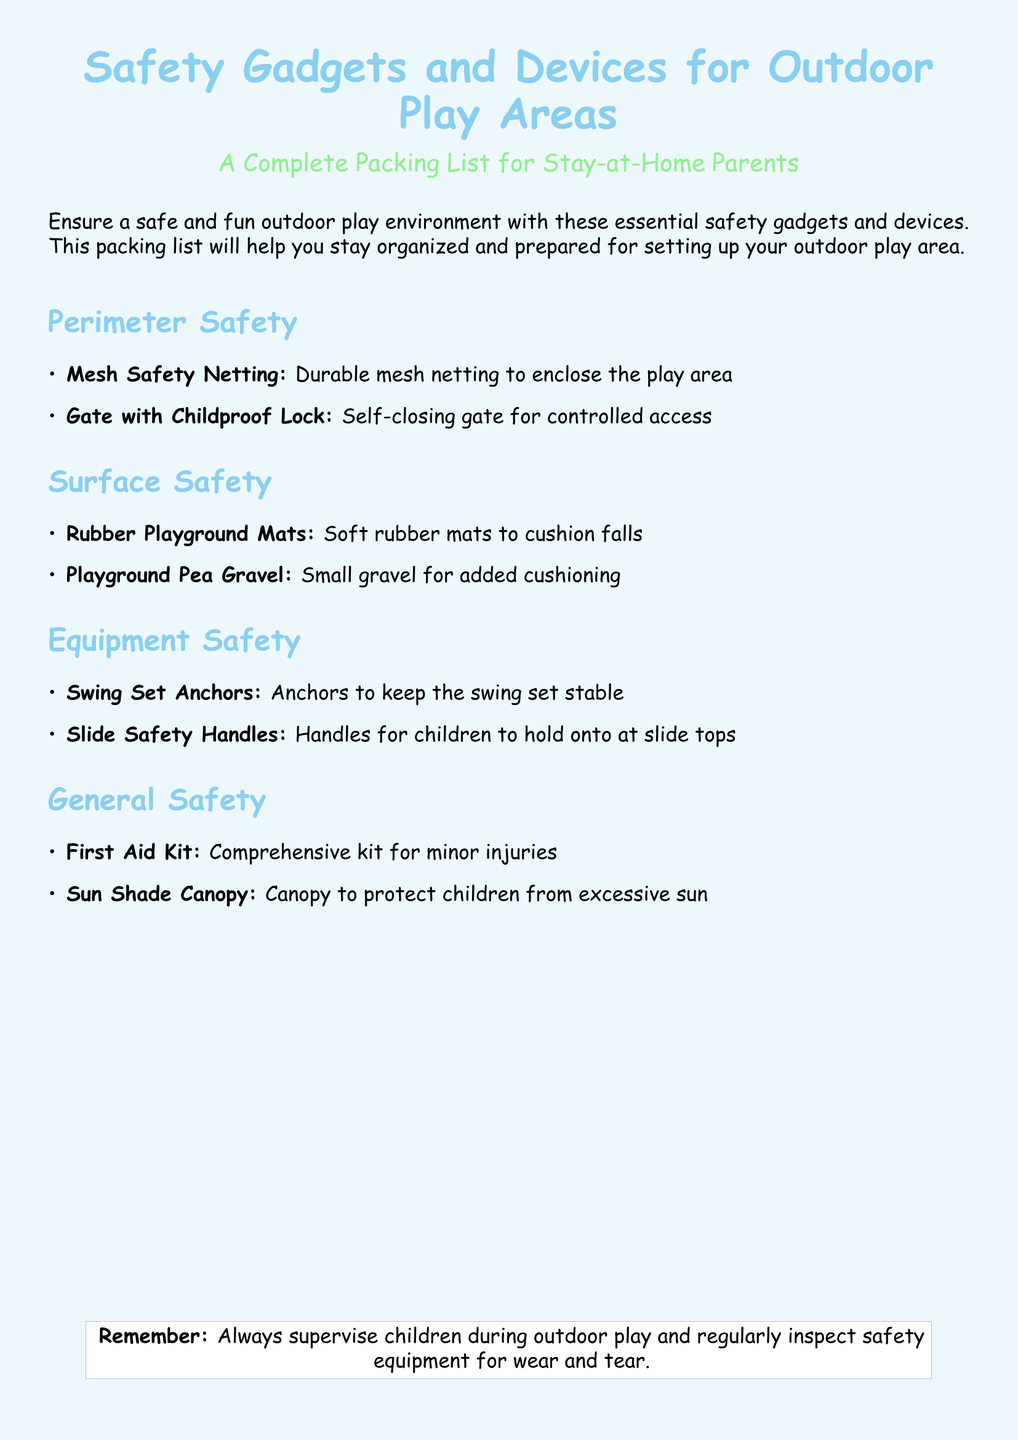What is the purpose of the document? The document provides a packing list to help stay-at-home parents ensure a safe and fun outdoor play environment.
Answer: A complete packing list How many sections are in the document? The document contains sections for perimeter safety, surface safety, equipment safety, and general safety, totaling four sections.
Answer: Four What type of safety device is recommended for enclosing the play area? The document recommends durable mesh netting for enclosing the play area.
Answer: Mesh Safety Netting What is included in the general safety items? The general safety items section includes a first aid kit and a sun shade canopy.
Answer: First Aid Kit, Sun Shade Canopy What should parents do regularly according to the document? The document advises parents to regularly inspect safety equipment for wear and tear.
Answer: Regularly inspect safety equipment 